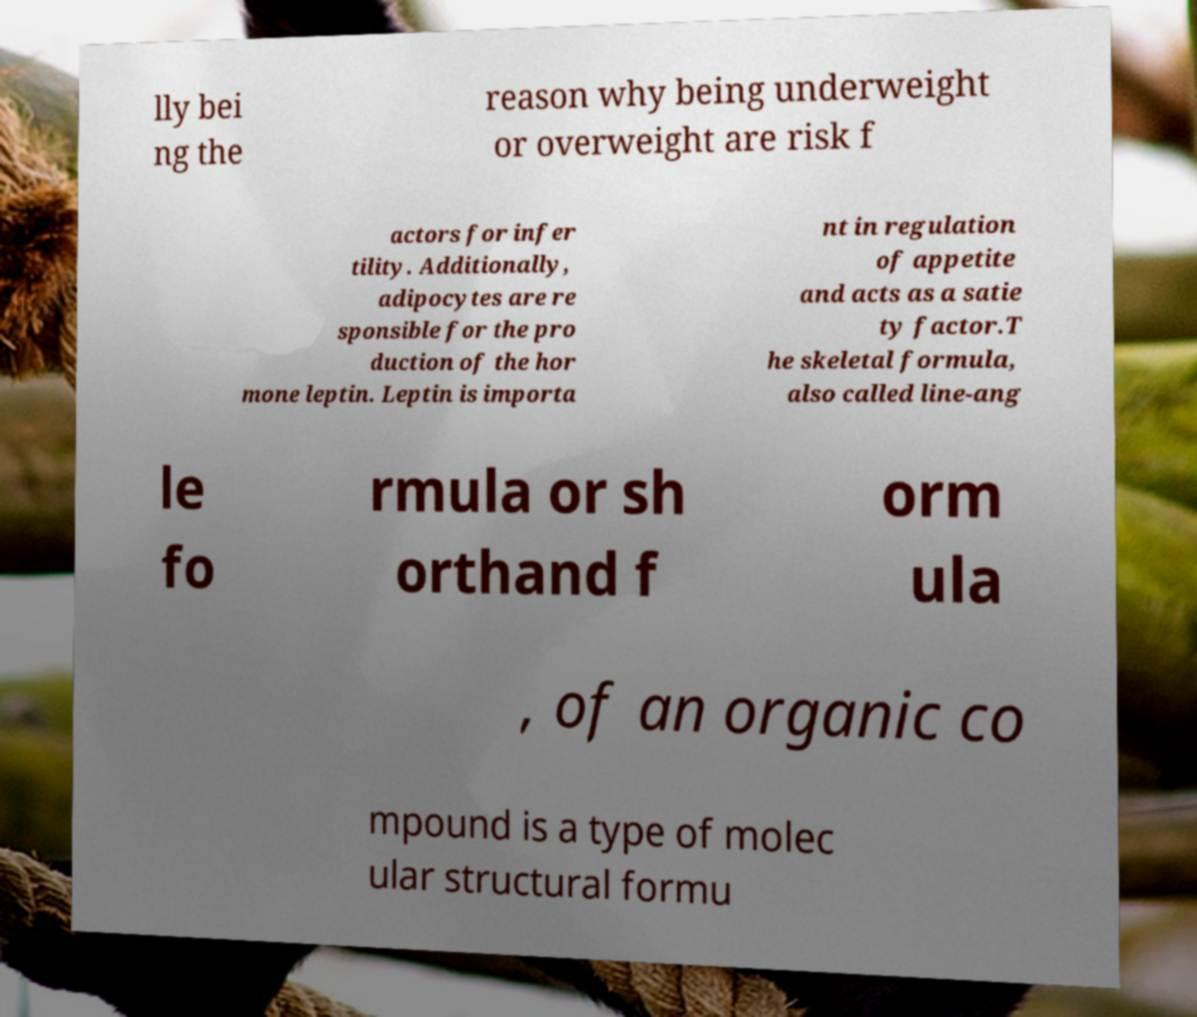Please identify and transcribe the text found in this image. lly bei ng the reason why being underweight or overweight are risk f actors for infer tility. Additionally, adipocytes are re sponsible for the pro duction of the hor mone leptin. Leptin is importa nt in regulation of appetite and acts as a satie ty factor.T he skeletal formula, also called line-ang le fo rmula or sh orthand f orm ula , of an organic co mpound is a type of molec ular structural formu 